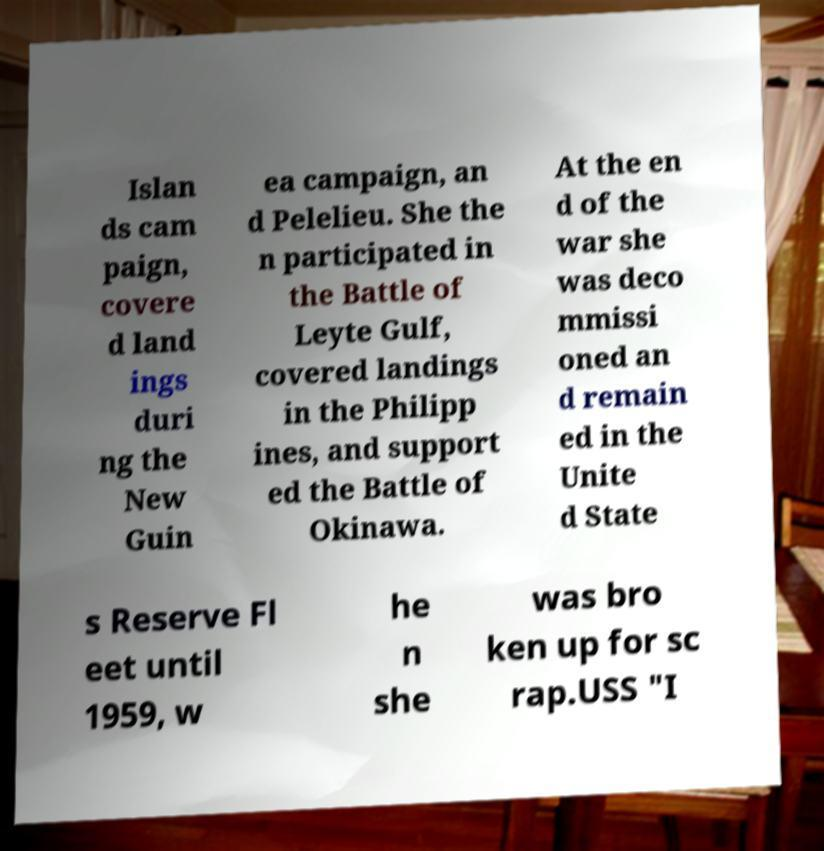There's text embedded in this image that I need extracted. Can you transcribe it verbatim? Islan ds cam paign, covere d land ings duri ng the New Guin ea campaign, an d Pelelieu. She the n participated in the Battle of Leyte Gulf, covered landings in the Philipp ines, and support ed the Battle of Okinawa. At the en d of the war she was deco mmissi oned an d remain ed in the Unite d State s Reserve Fl eet until 1959, w he n she was bro ken up for sc rap.USS "I 